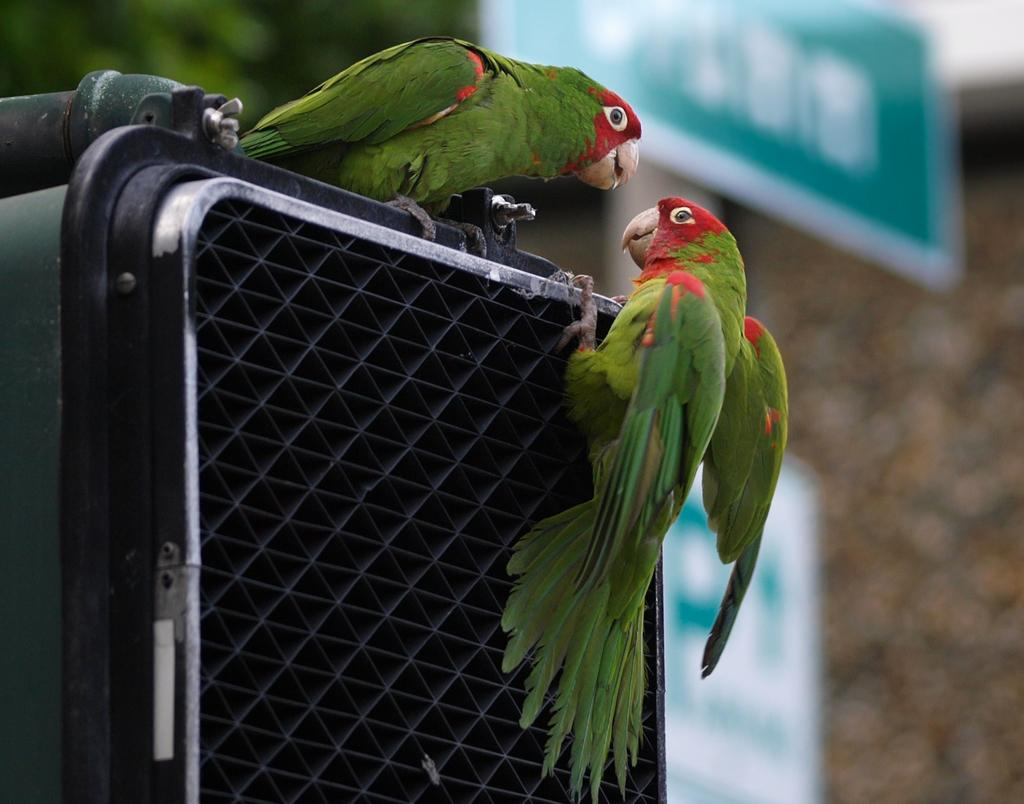What type of animals are in the image? There are two green parrots in the image. What is the parrots' living environment in the image? There is a cage in the image. What color is the board in the image? There is a green color board in the image. What can be seen in the background of the image? There are trees in the background of the image. What type of lipstick is the parrot wearing in the image? There are no parrots wearing lipstick in the image; they are simply green parrots in a cage. How does the slippery surface affect the parrots' movement in the image? There is no slippery surface mentioned in the image, and the parrots are inside a cage, so their movement is not affected by any slippery surface. 